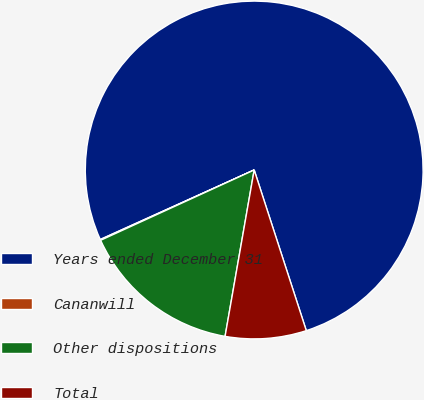Convert chart. <chart><loc_0><loc_0><loc_500><loc_500><pie_chart><fcel>Years ended December 31<fcel>Cananwill<fcel>Other dispositions<fcel>Total<nl><fcel>76.76%<fcel>0.08%<fcel>15.41%<fcel>7.75%<nl></chart> 